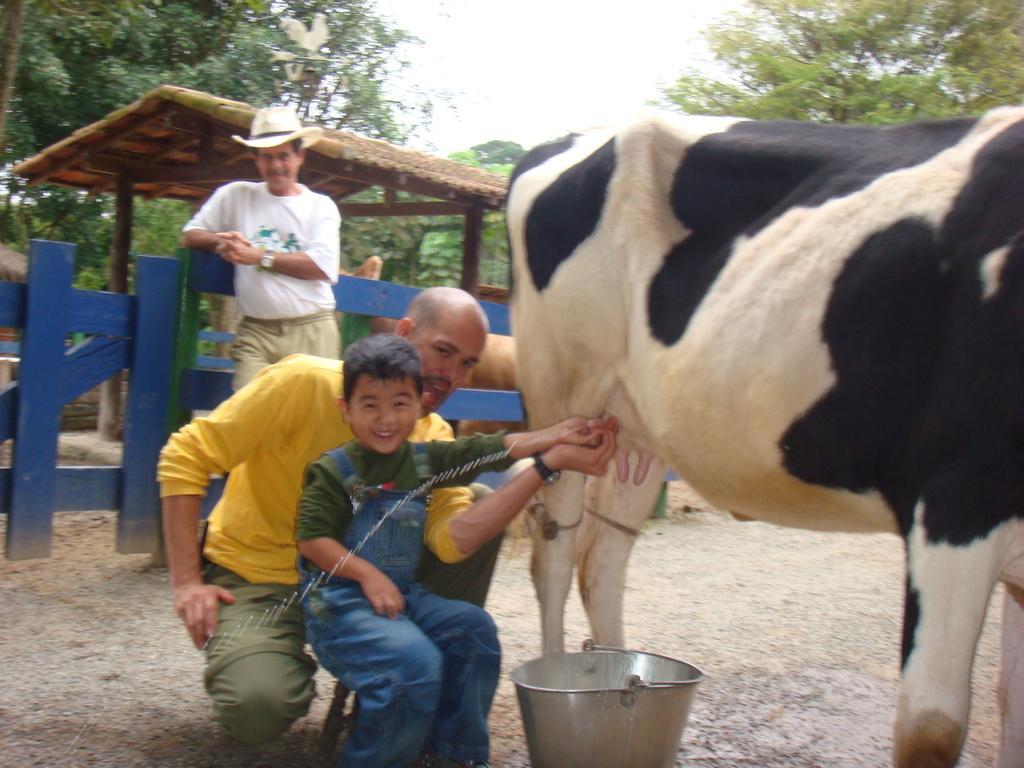Describe this image in one or two sentences. In this image there are two persons one person is sitting and one person is standing, and there is one boy who is sitting and smiling and on the right side there is one cow and a bucket. In the background there is a shed and some animals and trees, at the bottom there is a walkway. 